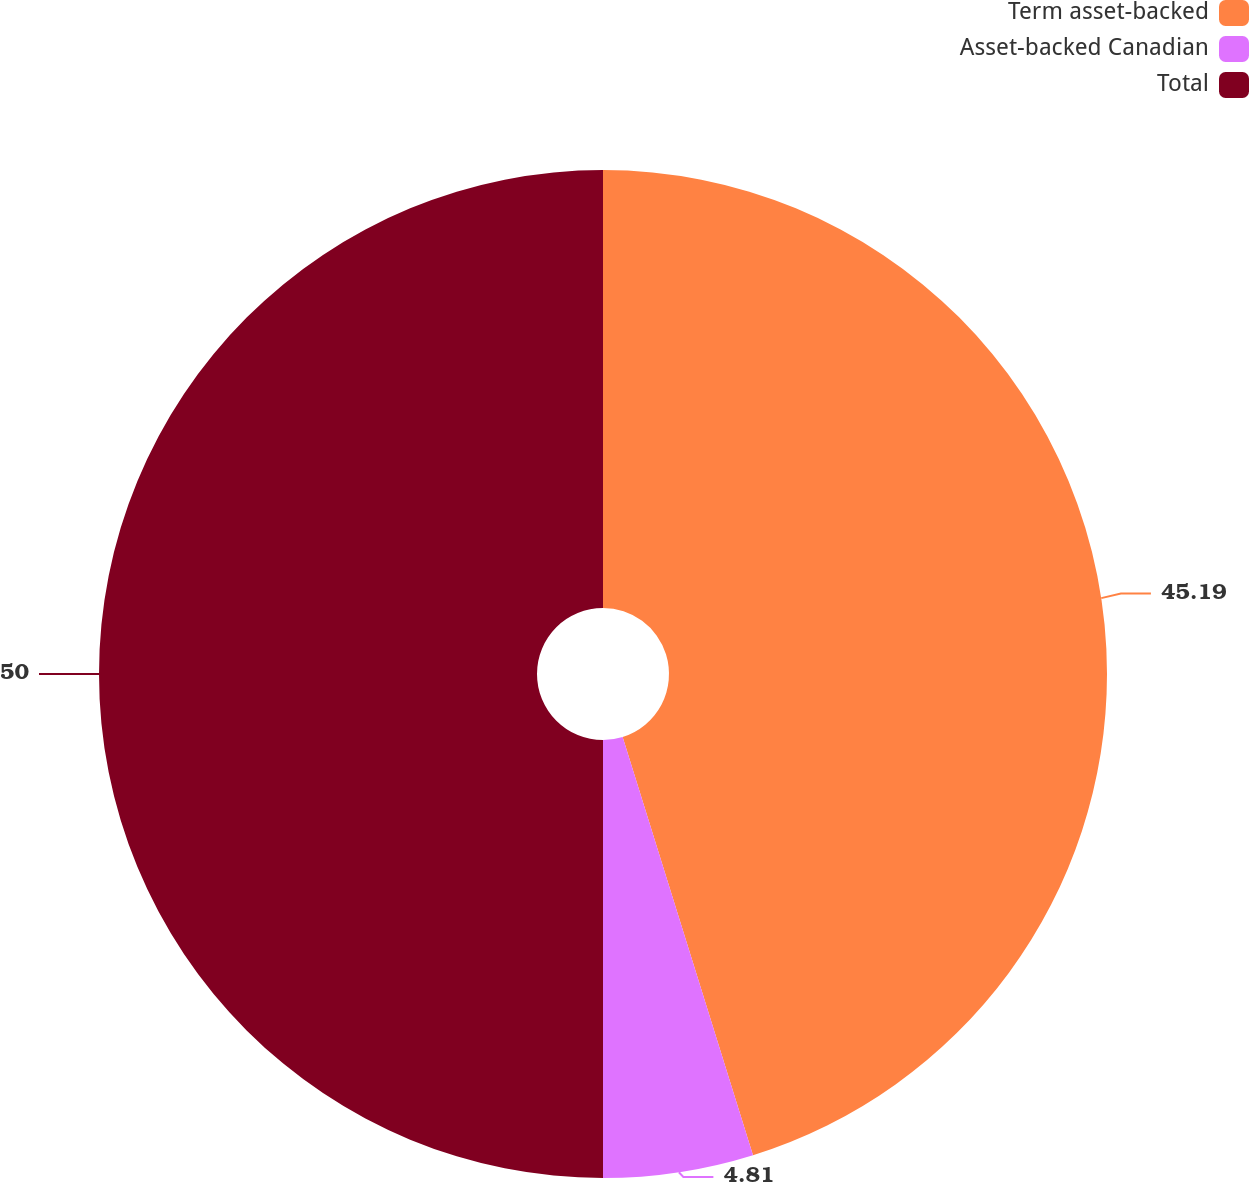<chart> <loc_0><loc_0><loc_500><loc_500><pie_chart><fcel>Term asset-backed<fcel>Asset-backed Canadian<fcel>Total<nl><fcel>45.19%<fcel>4.81%<fcel>50.0%<nl></chart> 